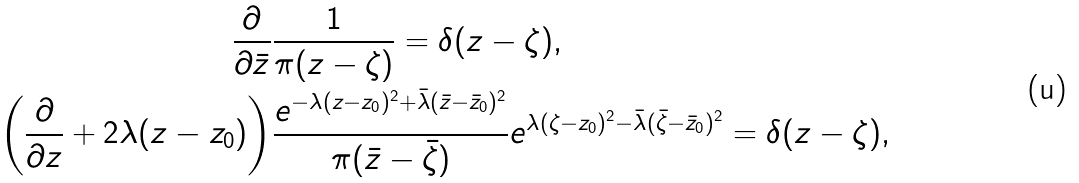<formula> <loc_0><loc_0><loc_500><loc_500>\frac { \partial } { \partial \bar { z } } & \frac { 1 } { \pi ( z - \zeta ) } = \delta ( z - \zeta ) , \\ \left ( \frac { \partial } { \partial z } + 2 \lambda ( z - z _ { 0 } ) \right ) & \frac { e ^ { - \lambda ( z - z _ { 0 } ) ^ { 2 } + \bar { \lambda } ( \bar { z } - \bar { z } _ { 0 } ) ^ { 2 } } } { \pi ( \bar { z } - \bar { \zeta } ) } e ^ { \lambda ( \zeta - z _ { 0 } ) ^ { 2 } - \bar { \lambda } ( \bar { \zeta } - \bar { z } _ { 0 } ) ^ { 2 } } = \delta ( z - \zeta ) ,</formula> 